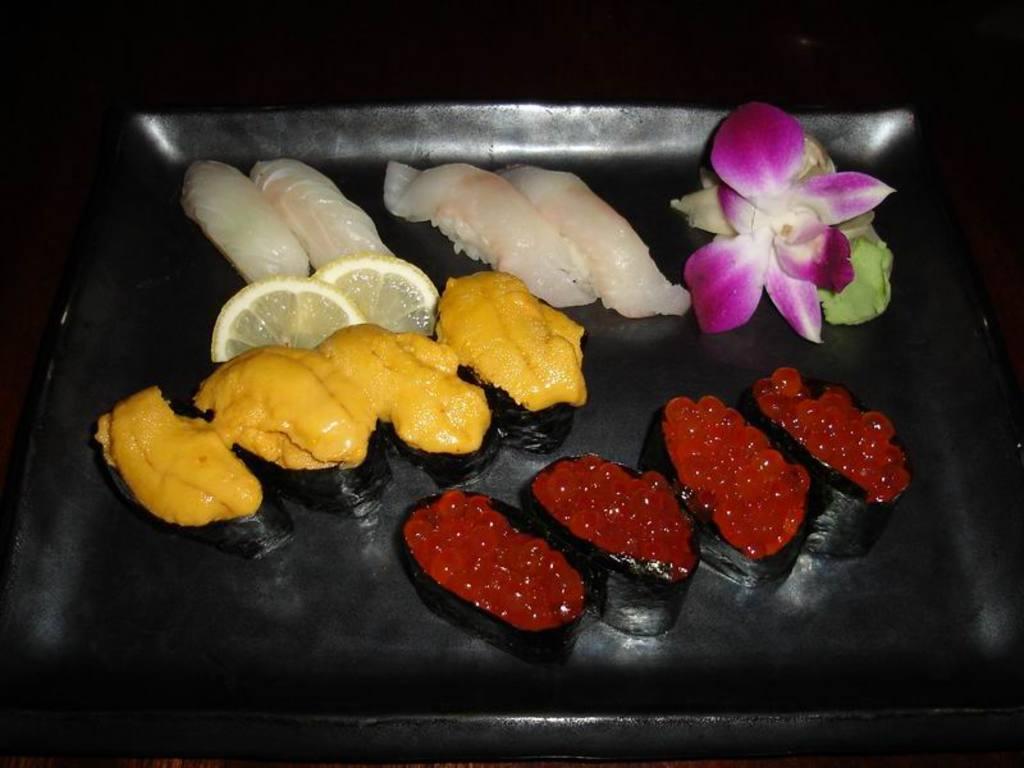In one or two sentences, can you explain what this image depicts? In this image, we can see some food items and a flower in a black color object. 